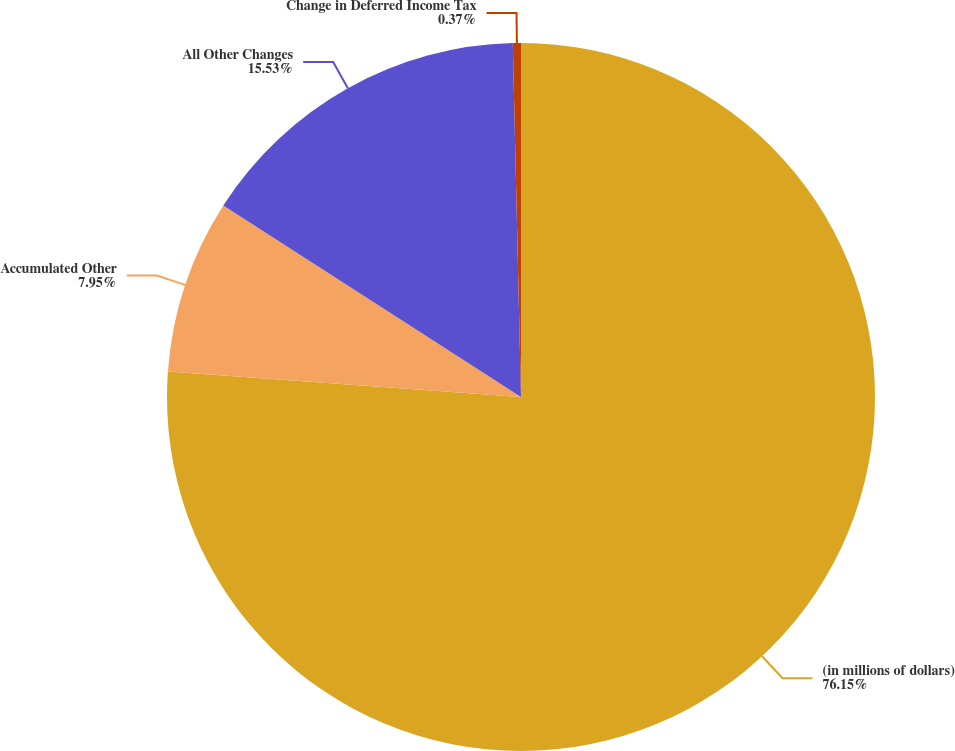Convert chart to OTSL. <chart><loc_0><loc_0><loc_500><loc_500><pie_chart><fcel>(in millions of dollars)<fcel>Accumulated Other<fcel>All Other Changes<fcel>Change in Deferred Income Tax<nl><fcel>76.16%<fcel>7.95%<fcel>15.53%<fcel>0.37%<nl></chart> 